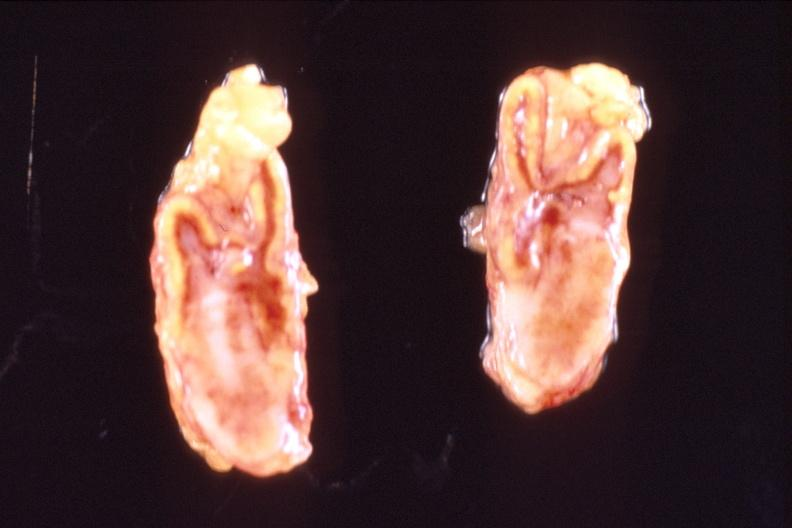what does this image show?
Answer the question using a single word or phrase. Adrenal glands 